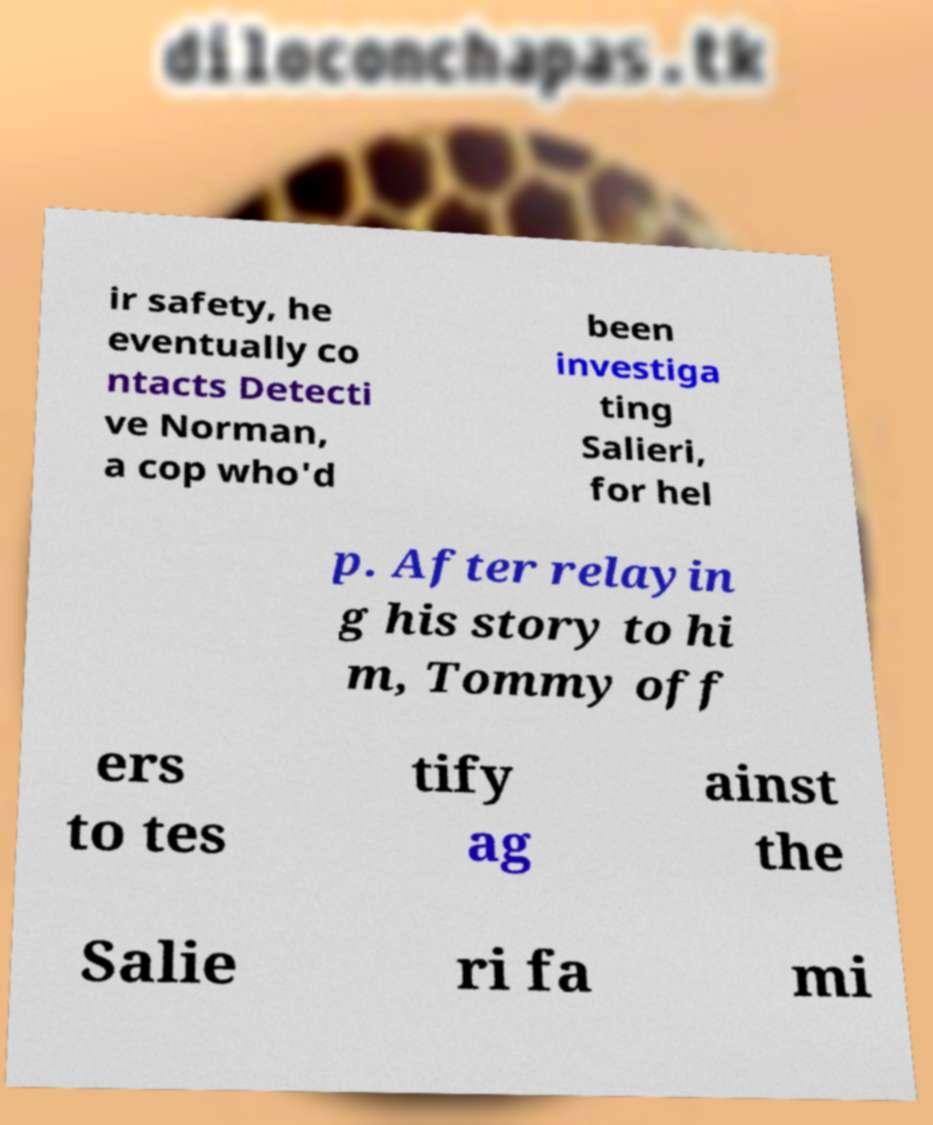Please identify and transcribe the text found in this image. ir safety, he eventually co ntacts Detecti ve Norman, a cop who'd been investiga ting Salieri, for hel p. After relayin g his story to hi m, Tommy off ers to tes tify ag ainst the Salie ri fa mi 